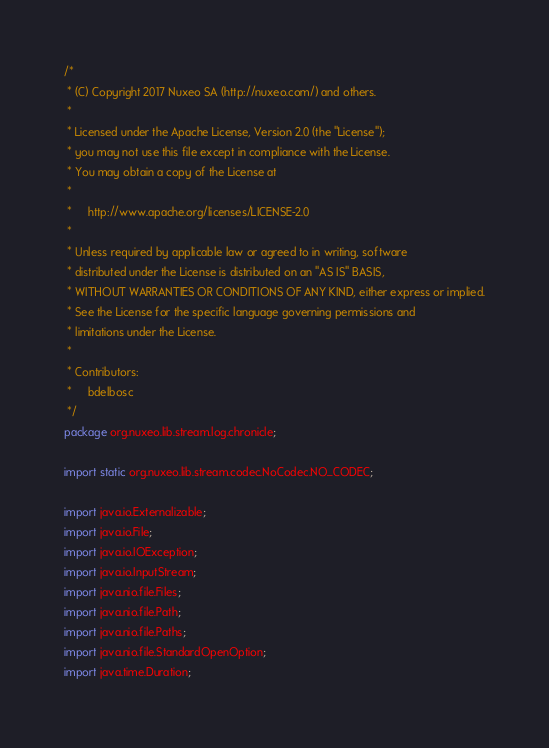Convert code to text. <code><loc_0><loc_0><loc_500><loc_500><_Java_>/*
 * (C) Copyright 2017 Nuxeo SA (http://nuxeo.com/) and others.
 *
 * Licensed under the Apache License, Version 2.0 (the "License");
 * you may not use this file except in compliance with the License.
 * You may obtain a copy of the License at
 *
 *     http://www.apache.org/licenses/LICENSE-2.0
 *
 * Unless required by applicable law or agreed to in writing, software
 * distributed under the License is distributed on an "AS IS" BASIS,
 * WITHOUT WARRANTIES OR CONDITIONS OF ANY KIND, either express or implied.
 * See the License for the specific language governing permissions and
 * limitations under the License.
 *
 * Contributors:
 *     bdelbosc
 */
package org.nuxeo.lib.stream.log.chronicle;

import static org.nuxeo.lib.stream.codec.NoCodec.NO_CODEC;

import java.io.Externalizable;
import java.io.File;
import java.io.IOException;
import java.io.InputStream;
import java.nio.file.Files;
import java.nio.file.Path;
import java.nio.file.Paths;
import java.nio.file.StandardOpenOption;
import java.time.Duration;</code> 